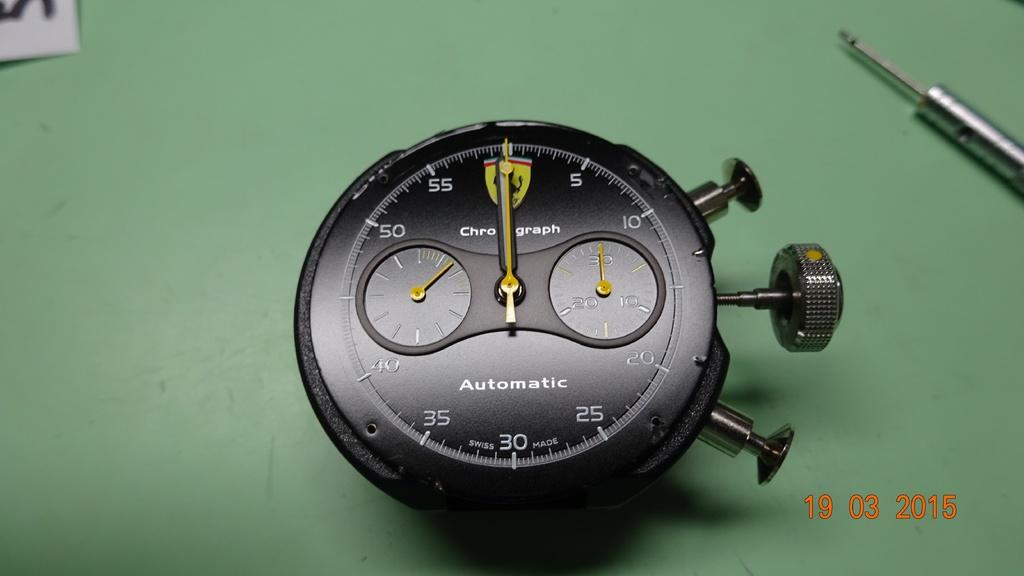<image>
Render a clear and concise summary of the photo. A watch face has the word automatic on it. 